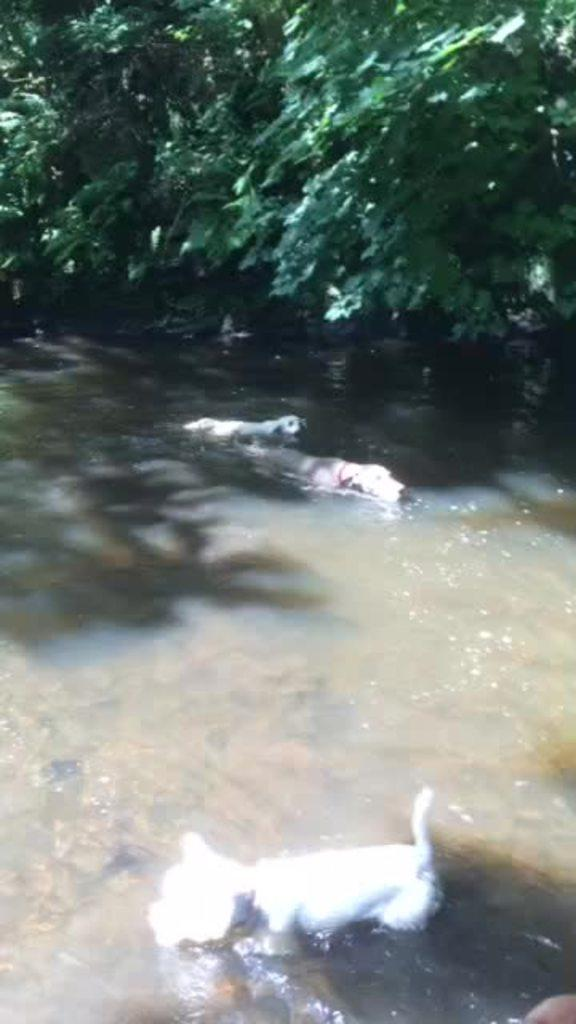What is the main feature in the image? There is a canal in the image. What animals can be seen in the canal? There are three dogs in the canal. What can be seen in the background of the image? There are plants in the background of the image. What stage of development is the grandfather in the image? There is no mention of a grandfather or any development stage in the image. 